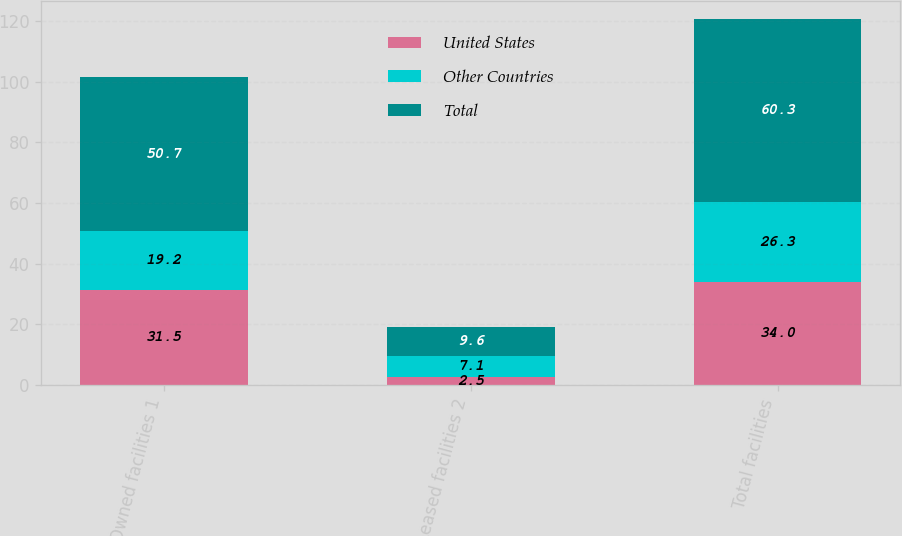Convert chart. <chart><loc_0><loc_0><loc_500><loc_500><stacked_bar_chart><ecel><fcel>Owned facilities 1<fcel>Leased facilities 2<fcel>Total facilities<nl><fcel>United States<fcel>31.5<fcel>2.5<fcel>34<nl><fcel>Other Countries<fcel>19.2<fcel>7.1<fcel>26.3<nl><fcel>Total<fcel>50.7<fcel>9.6<fcel>60.3<nl></chart> 